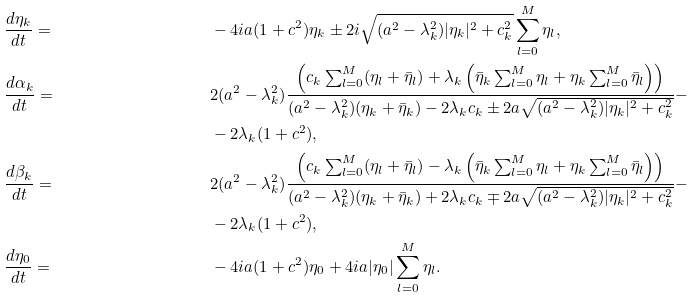<formula> <loc_0><loc_0><loc_500><loc_500>& \frac { d \eta _ { k } } { d t } = & & - 4 i a ( 1 + c ^ { 2 } ) \eta _ { k } \pm 2 i \sqrt { ( a ^ { 2 } - \lambda _ { k } ^ { 2 } ) | \eta _ { k } | ^ { 2 } + c _ { k } ^ { 2 } } \sum _ { l = 0 } ^ { M } \eta _ { l } , \\ & \frac { d \alpha _ { k } } { d t } = & & 2 ( a ^ { 2 } - \lambda _ { k } ^ { 2 } ) \frac { \left ( c _ { k } \sum _ { l = 0 } ^ { M } ( \eta _ { l } + \bar { \eta } _ { l } ) + \lambda _ { k } \left ( \bar { \eta } _ { k } \sum _ { l = 0 } ^ { M } \eta _ { l } + \eta _ { k } \sum _ { l = 0 } ^ { M } \bar { \eta } _ { l } \right ) \right ) } { ( a ^ { 2 } - \lambda _ { k } ^ { 2 } ) ( \eta _ { k } + \bar { \eta } _ { k } ) - 2 \lambda _ { k } c _ { k } \pm 2 a \sqrt { ( a ^ { 2 } - \lambda _ { k } ^ { 2 } ) | \eta _ { k } | ^ { 2 } + c _ { k } ^ { 2 } } } - \\ & & & - 2 \lambda _ { k } ( 1 + c ^ { 2 } ) , \\ & \frac { d \beta _ { k } } { d t } = & & 2 ( a ^ { 2 } - \lambda _ { k } ^ { 2 } ) \frac { \left ( c _ { k } \sum _ { l = 0 } ^ { M } ( \eta _ { l } + \bar { \eta } _ { l } ) - \lambda _ { k } \left ( \bar { \eta } _ { k } \sum _ { l = 0 } ^ { M } \eta _ { l } + \eta _ { k } \sum _ { l = 0 } ^ { M } \bar { \eta } _ { l } \right ) \right ) } { ( a ^ { 2 } - \lambda _ { k } ^ { 2 } ) ( \eta _ { k } + \bar { \eta } _ { k } ) + 2 \lambda _ { k } c _ { k } \mp 2 a \sqrt { ( a ^ { 2 } - \lambda _ { k } ^ { 2 } ) | \eta _ { k } | ^ { 2 } + c _ { k } ^ { 2 } } } - \\ & & & - 2 \lambda _ { k } ( 1 + c ^ { 2 } ) , \\ & \frac { d \eta _ { 0 } } { d t } = & & - 4 i a ( 1 + c ^ { 2 } ) \eta _ { 0 } + 4 i a | \eta _ { 0 } | \sum _ { l = 0 } ^ { M } \eta _ { l } .</formula> 